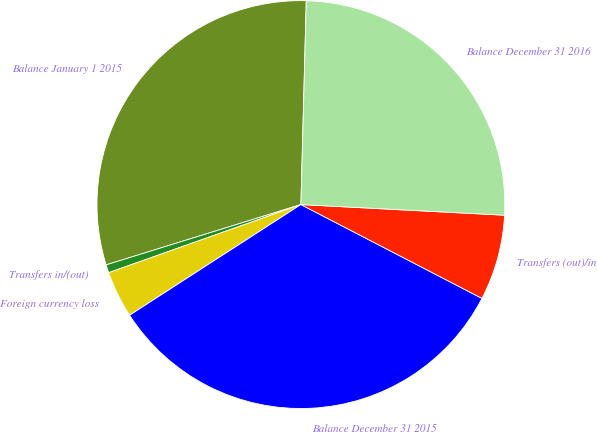Convert chart to OTSL. <chart><loc_0><loc_0><loc_500><loc_500><pie_chart><fcel>Balance January 1 2015<fcel>Transfers in/(out)<fcel>Foreign currency loss<fcel>Balance December 31 2015<fcel>Transfers (out)/in<fcel>Balance December 31 2016<nl><fcel>30.2%<fcel>0.64%<fcel>3.71%<fcel>33.26%<fcel>6.78%<fcel>25.41%<nl></chart> 